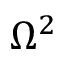<formula> <loc_0><loc_0><loc_500><loc_500>\Omega ^ { 2 }</formula> 